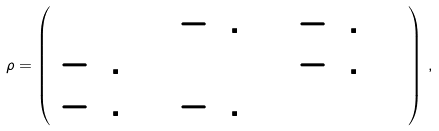Convert formula to latex. <formula><loc_0><loc_0><loc_500><loc_500>\rho = \left ( \begin{array} { c c c } 1 & - 0 . 3 2 & - 0 . 1 2 \\ - 0 . 3 2 & 1 & - 0 . 0 4 \\ - 0 . 1 2 & - 0 . 0 4 & 1 \end{array} \right ) \, ,</formula> 